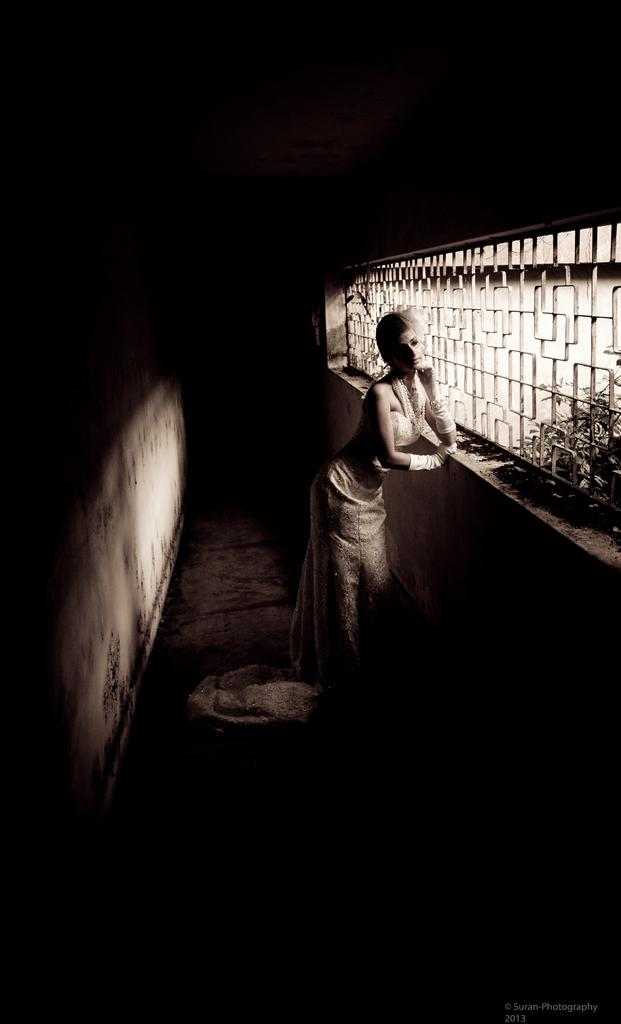Who is the main subject in the image? There is a lady standing in the center of the image. What can be seen in the background of the image? There is a window in the image. What is on the left side of the image? There is a wall on the left side of the image. What type of bird is sitting on the lady's shoulder in the image? There is no bird present in the image. How many nuts can be seen on the wall in the image? There are no nuts visible on the wall in the image. 